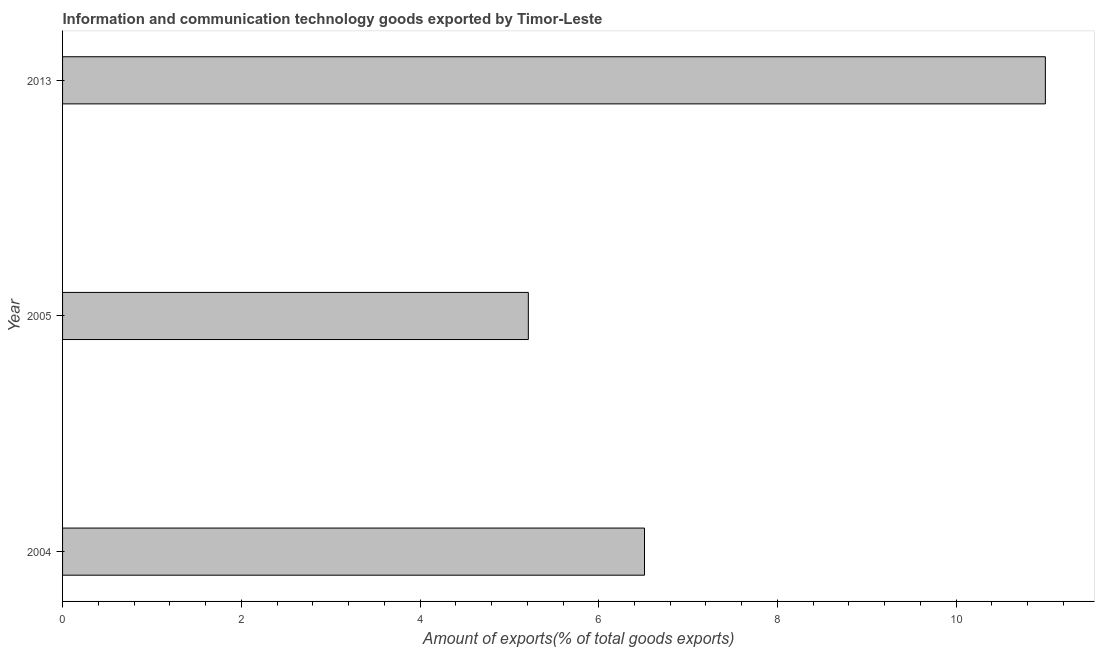What is the title of the graph?
Offer a terse response. Information and communication technology goods exported by Timor-Leste. What is the label or title of the X-axis?
Your answer should be compact. Amount of exports(% of total goods exports). What is the amount of ict goods exports in 2005?
Offer a very short reply. 5.21. Across all years, what is the maximum amount of ict goods exports?
Your answer should be very brief. 11. Across all years, what is the minimum amount of ict goods exports?
Offer a terse response. 5.21. In which year was the amount of ict goods exports maximum?
Keep it short and to the point. 2013. What is the sum of the amount of ict goods exports?
Offer a terse response. 22.72. What is the difference between the amount of ict goods exports in 2005 and 2013?
Give a very brief answer. -5.79. What is the average amount of ict goods exports per year?
Offer a terse response. 7.57. What is the median amount of ict goods exports?
Give a very brief answer. 6.51. In how many years, is the amount of ict goods exports greater than 2 %?
Offer a very short reply. 3. What is the ratio of the amount of ict goods exports in 2005 to that in 2013?
Make the answer very short. 0.47. Is the amount of ict goods exports in 2004 less than that in 2005?
Offer a terse response. No. What is the difference between the highest and the second highest amount of ict goods exports?
Provide a succinct answer. 4.49. Is the sum of the amount of ict goods exports in 2005 and 2013 greater than the maximum amount of ict goods exports across all years?
Your response must be concise. Yes. What is the difference between the highest and the lowest amount of ict goods exports?
Your answer should be very brief. 5.79. How many bars are there?
Your response must be concise. 3. Are the values on the major ticks of X-axis written in scientific E-notation?
Provide a short and direct response. No. What is the Amount of exports(% of total goods exports) in 2004?
Provide a short and direct response. 6.51. What is the Amount of exports(% of total goods exports) of 2005?
Give a very brief answer. 5.21. What is the Amount of exports(% of total goods exports) of 2013?
Ensure brevity in your answer.  11. What is the difference between the Amount of exports(% of total goods exports) in 2004 and 2005?
Make the answer very short. 1.3. What is the difference between the Amount of exports(% of total goods exports) in 2004 and 2013?
Offer a terse response. -4.49. What is the difference between the Amount of exports(% of total goods exports) in 2005 and 2013?
Keep it short and to the point. -5.79. What is the ratio of the Amount of exports(% of total goods exports) in 2004 to that in 2005?
Your answer should be compact. 1.25. What is the ratio of the Amount of exports(% of total goods exports) in 2004 to that in 2013?
Your response must be concise. 0.59. What is the ratio of the Amount of exports(% of total goods exports) in 2005 to that in 2013?
Give a very brief answer. 0.47. 